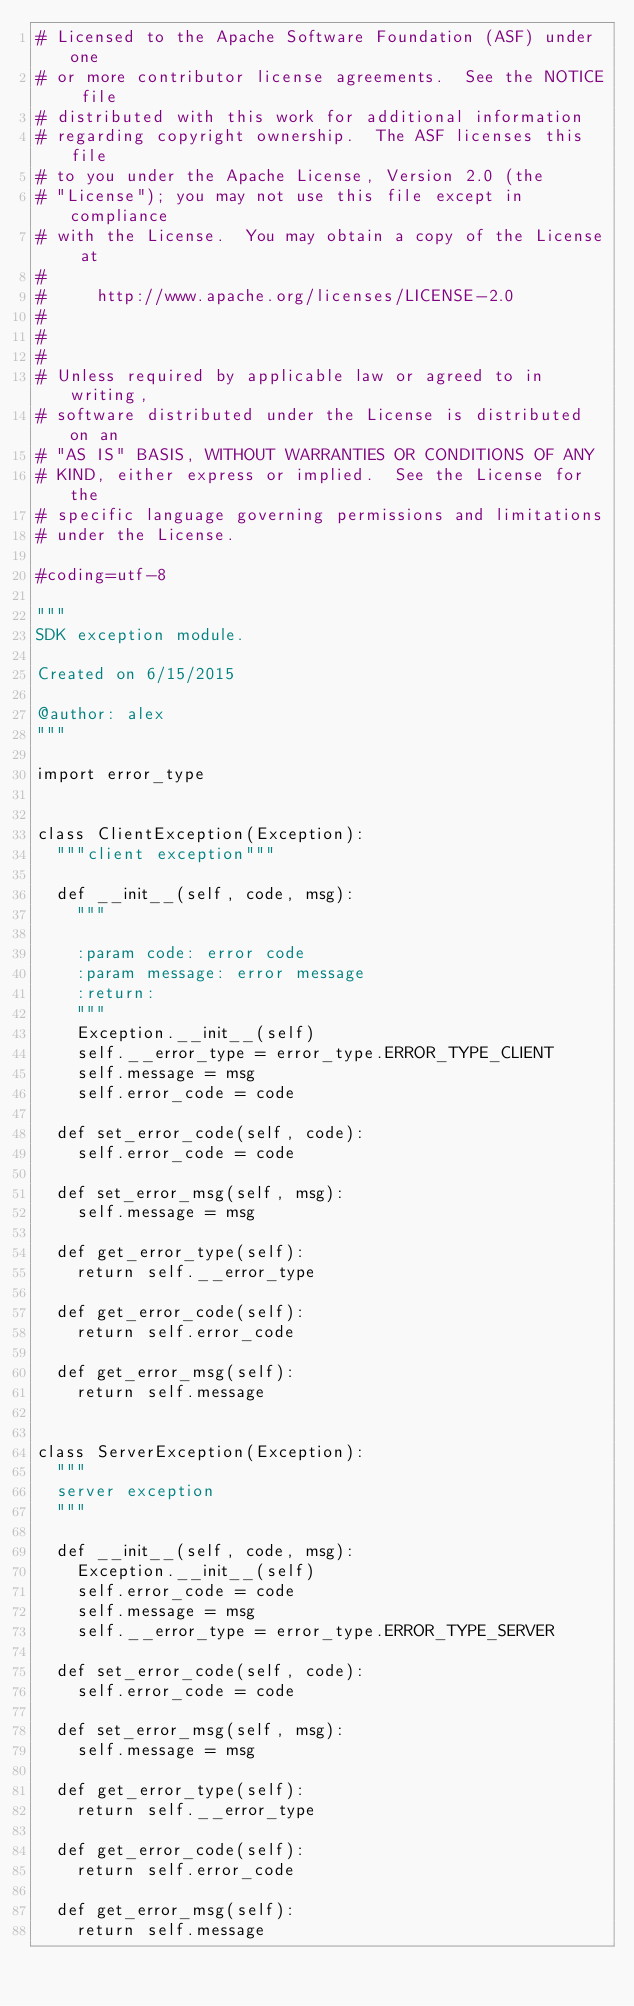Convert code to text. <code><loc_0><loc_0><loc_500><loc_500><_Python_># Licensed to the Apache Software Foundation (ASF) under one
# or more contributor license agreements.  See the NOTICE file
# distributed with this work for additional information
# regarding copyright ownership.  The ASF licenses this file
# to you under the Apache License, Version 2.0 (the
# "License"); you may not use this file except in compliance
# with the License.  You may obtain a copy of the License at
#
#     http://www.apache.org/licenses/LICENSE-2.0
#
#
#
# Unless required by applicable law or agreed to in writing,
# software distributed under the License is distributed on an
# "AS IS" BASIS, WITHOUT WARRANTIES OR CONDITIONS OF ANY
# KIND, either express or implied.  See the License for the
# specific language governing permissions and limitations
# under the License.

#coding=utf-8

"""
SDK exception module.

Created on 6/15/2015

@author: alex
"""

import error_type


class ClientException(Exception):
	"""client exception"""

	def __init__(self, code, msg):
		"""

		:param code: error code
		:param message: error message
		:return:
		"""
		Exception.__init__(self)
		self.__error_type = error_type.ERROR_TYPE_CLIENT
		self.message = msg
		self.error_code = code

	def set_error_code(self, code):
		self.error_code = code

	def set_error_msg(self, msg):
		self.message = msg

	def get_error_type(self):
		return self.__error_type

	def get_error_code(self):
		return self.error_code

	def get_error_msg(self):
		return self.message


class ServerException(Exception):
	"""
	server exception
	"""

	def __init__(self, code, msg):
		Exception.__init__(self)
		self.error_code = code
		self.message = msg
		self.__error_type = error_type.ERROR_TYPE_SERVER

	def set_error_code(self, code):
		self.error_code = code

	def set_error_msg(self, msg):
		self.message = msg

	def get_error_type(self):
		return self.__error_type

	def get_error_code(self):
		return self.error_code

	def get_error_msg(self):
		return self.message
</code> 